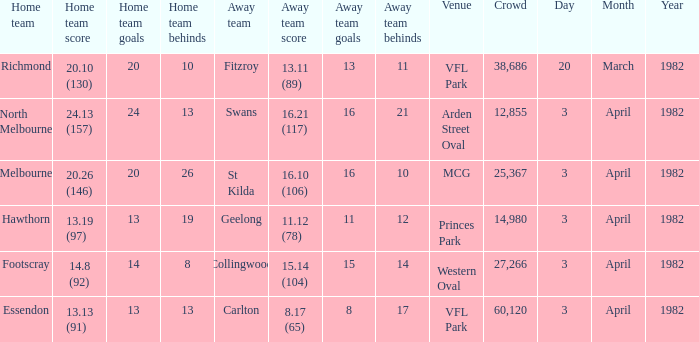Which home team played the away team of collingwood? Footscray. 